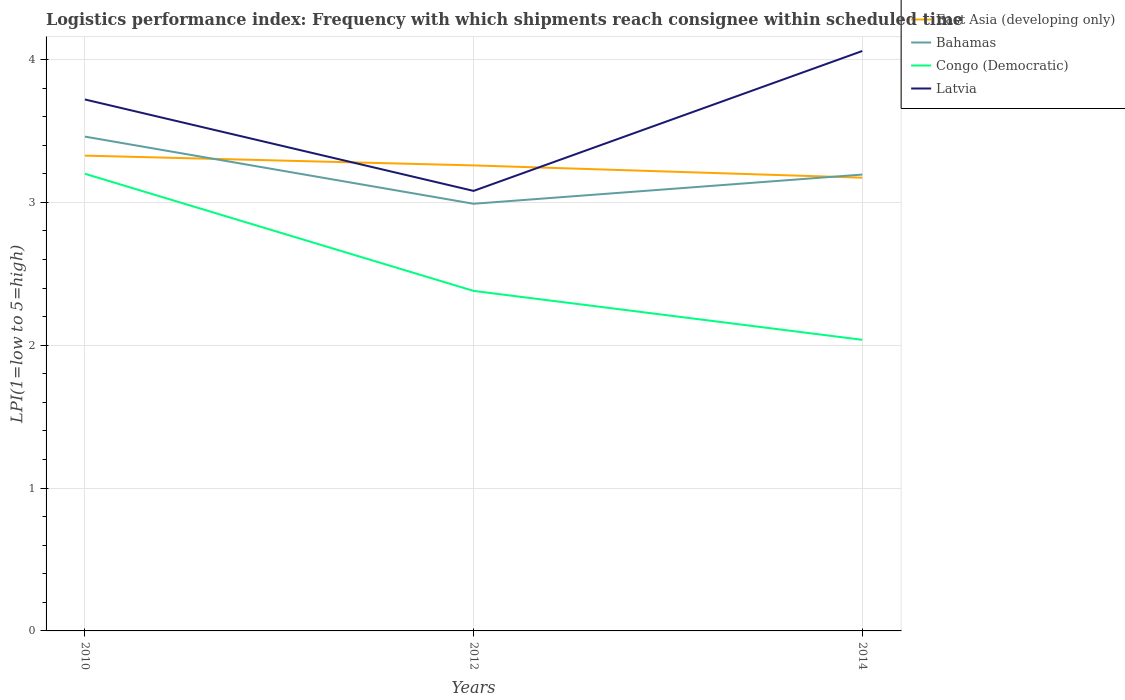Across all years, what is the maximum logistics performance index in East Asia (developing only)?
Offer a terse response. 3.17. In which year was the logistics performance index in Bahamas maximum?
Provide a succinct answer. 2012. What is the total logistics performance index in Latvia in the graph?
Provide a succinct answer. -0.34. What is the difference between the highest and the second highest logistics performance index in Congo (Democratic)?
Your answer should be very brief. 1.16. Is the logistics performance index in East Asia (developing only) strictly greater than the logistics performance index in Latvia over the years?
Give a very brief answer. No. How many lines are there?
Keep it short and to the point. 4. How many years are there in the graph?
Ensure brevity in your answer.  3. What is the difference between two consecutive major ticks on the Y-axis?
Your response must be concise. 1. Are the values on the major ticks of Y-axis written in scientific E-notation?
Keep it short and to the point. No. How many legend labels are there?
Make the answer very short. 4. What is the title of the graph?
Make the answer very short. Logistics performance index: Frequency with which shipments reach consignee within scheduled time. What is the label or title of the X-axis?
Make the answer very short. Years. What is the label or title of the Y-axis?
Ensure brevity in your answer.  LPI(1=low to 5=high). What is the LPI(1=low to 5=high) of East Asia (developing only) in 2010?
Keep it short and to the point. 3.33. What is the LPI(1=low to 5=high) in Bahamas in 2010?
Your answer should be very brief. 3.46. What is the LPI(1=low to 5=high) of Congo (Democratic) in 2010?
Offer a terse response. 3.2. What is the LPI(1=low to 5=high) of Latvia in 2010?
Give a very brief answer. 3.72. What is the LPI(1=low to 5=high) in East Asia (developing only) in 2012?
Your answer should be very brief. 3.26. What is the LPI(1=low to 5=high) in Bahamas in 2012?
Ensure brevity in your answer.  2.99. What is the LPI(1=low to 5=high) of Congo (Democratic) in 2012?
Keep it short and to the point. 2.38. What is the LPI(1=low to 5=high) in Latvia in 2012?
Your answer should be compact. 3.08. What is the LPI(1=low to 5=high) in East Asia (developing only) in 2014?
Your response must be concise. 3.17. What is the LPI(1=low to 5=high) of Bahamas in 2014?
Ensure brevity in your answer.  3.19. What is the LPI(1=low to 5=high) in Congo (Democratic) in 2014?
Keep it short and to the point. 2.04. What is the LPI(1=low to 5=high) in Latvia in 2014?
Provide a succinct answer. 4.06. Across all years, what is the maximum LPI(1=low to 5=high) in East Asia (developing only)?
Offer a very short reply. 3.33. Across all years, what is the maximum LPI(1=low to 5=high) in Bahamas?
Provide a short and direct response. 3.46. Across all years, what is the maximum LPI(1=low to 5=high) in Latvia?
Your answer should be very brief. 4.06. Across all years, what is the minimum LPI(1=low to 5=high) of East Asia (developing only)?
Ensure brevity in your answer.  3.17. Across all years, what is the minimum LPI(1=low to 5=high) of Bahamas?
Keep it short and to the point. 2.99. Across all years, what is the minimum LPI(1=low to 5=high) of Congo (Democratic)?
Provide a succinct answer. 2.04. Across all years, what is the minimum LPI(1=low to 5=high) in Latvia?
Make the answer very short. 3.08. What is the total LPI(1=low to 5=high) in East Asia (developing only) in the graph?
Ensure brevity in your answer.  9.76. What is the total LPI(1=low to 5=high) in Bahamas in the graph?
Your answer should be compact. 9.64. What is the total LPI(1=low to 5=high) of Congo (Democratic) in the graph?
Your answer should be compact. 7.62. What is the total LPI(1=low to 5=high) of Latvia in the graph?
Offer a very short reply. 10.86. What is the difference between the LPI(1=low to 5=high) of East Asia (developing only) in 2010 and that in 2012?
Offer a very short reply. 0.07. What is the difference between the LPI(1=low to 5=high) of Bahamas in 2010 and that in 2012?
Give a very brief answer. 0.47. What is the difference between the LPI(1=low to 5=high) in Congo (Democratic) in 2010 and that in 2012?
Your answer should be compact. 0.82. What is the difference between the LPI(1=low to 5=high) of Latvia in 2010 and that in 2012?
Your response must be concise. 0.64. What is the difference between the LPI(1=low to 5=high) of East Asia (developing only) in 2010 and that in 2014?
Your answer should be very brief. 0.15. What is the difference between the LPI(1=low to 5=high) in Bahamas in 2010 and that in 2014?
Provide a short and direct response. 0.27. What is the difference between the LPI(1=low to 5=high) of Congo (Democratic) in 2010 and that in 2014?
Offer a terse response. 1.16. What is the difference between the LPI(1=low to 5=high) of Latvia in 2010 and that in 2014?
Give a very brief answer. -0.34. What is the difference between the LPI(1=low to 5=high) of East Asia (developing only) in 2012 and that in 2014?
Offer a very short reply. 0.09. What is the difference between the LPI(1=low to 5=high) of Bahamas in 2012 and that in 2014?
Provide a succinct answer. -0.2. What is the difference between the LPI(1=low to 5=high) of Congo (Democratic) in 2012 and that in 2014?
Give a very brief answer. 0.34. What is the difference between the LPI(1=low to 5=high) in Latvia in 2012 and that in 2014?
Offer a terse response. -0.98. What is the difference between the LPI(1=low to 5=high) of East Asia (developing only) in 2010 and the LPI(1=low to 5=high) of Bahamas in 2012?
Offer a terse response. 0.34. What is the difference between the LPI(1=low to 5=high) in East Asia (developing only) in 2010 and the LPI(1=low to 5=high) in Congo (Democratic) in 2012?
Offer a terse response. 0.95. What is the difference between the LPI(1=low to 5=high) in East Asia (developing only) in 2010 and the LPI(1=low to 5=high) in Latvia in 2012?
Your answer should be very brief. 0.25. What is the difference between the LPI(1=low to 5=high) of Bahamas in 2010 and the LPI(1=low to 5=high) of Latvia in 2012?
Give a very brief answer. 0.38. What is the difference between the LPI(1=low to 5=high) in Congo (Democratic) in 2010 and the LPI(1=low to 5=high) in Latvia in 2012?
Keep it short and to the point. 0.12. What is the difference between the LPI(1=low to 5=high) in East Asia (developing only) in 2010 and the LPI(1=low to 5=high) in Bahamas in 2014?
Make the answer very short. 0.13. What is the difference between the LPI(1=low to 5=high) in East Asia (developing only) in 2010 and the LPI(1=low to 5=high) in Congo (Democratic) in 2014?
Provide a succinct answer. 1.29. What is the difference between the LPI(1=low to 5=high) of East Asia (developing only) in 2010 and the LPI(1=low to 5=high) of Latvia in 2014?
Ensure brevity in your answer.  -0.73. What is the difference between the LPI(1=low to 5=high) in Bahamas in 2010 and the LPI(1=low to 5=high) in Congo (Democratic) in 2014?
Keep it short and to the point. 1.42. What is the difference between the LPI(1=low to 5=high) of Bahamas in 2010 and the LPI(1=low to 5=high) of Latvia in 2014?
Ensure brevity in your answer.  -0.6. What is the difference between the LPI(1=low to 5=high) of Congo (Democratic) in 2010 and the LPI(1=low to 5=high) of Latvia in 2014?
Offer a very short reply. -0.86. What is the difference between the LPI(1=low to 5=high) of East Asia (developing only) in 2012 and the LPI(1=low to 5=high) of Bahamas in 2014?
Your answer should be compact. 0.06. What is the difference between the LPI(1=low to 5=high) of East Asia (developing only) in 2012 and the LPI(1=low to 5=high) of Congo (Democratic) in 2014?
Give a very brief answer. 1.22. What is the difference between the LPI(1=low to 5=high) of East Asia (developing only) in 2012 and the LPI(1=low to 5=high) of Latvia in 2014?
Give a very brief answer. -0.8. What is the difference between the LPI(1=low to 5=high) of Bahamas in 2012 and the LPI(1=low to 5=high) of Congo (Democratic) in 2014?
Keep it short and to the point. 0.95. What is the difference between the LPI(1=low to 5=high) in Bahamas in 2012 and the LPI(1=low to 5=high) in Latvia in 2014?
Keep it short and to the point. -1.07. What is the difference between the LPI(1=low to 5=high) in Congo (Democratic) in 2012 and the LPI(1=low to 5=high) in Latvia in 2014?
Make the answer very short. -1.68. What is the average LPI(1=low to 5=high) in East Asia (developing only) per year?
Make the answer very short. 3.25. What is the average LPI(1=low to 5=high) of Bahamas per year?
Your answer should be very brief. 3.21. What is the average LPI(1=low to 5=high) in Congo (Democratic) per year?
Provide a short and direct response. 2.54. What is the average LPI(1=low to 5=high) in Latvia per year?
Your answer should be compact. 3.62. In the year 2010, what is the difference between the LPI(1=low to 5=high) of East Asia (developing only) and LPI(1=low to 5=high) of Bahamas?
Ensure brevity in your answer.  -0.13. In the year 2010, what is the difference between the LPI(1=low to 5=high) in East Asia (developing only) and LPI(1=low to 5=high) in Congo (Democratic)?
Provide a short and direct response. 0.13. In the year 2010, what is the difference between the LPI(1=low to 5=high) in East Asia (developing only) and LPI(1=low to 5=high) in Latvia?
Make the answer very short. -0.39. In the year 2010, what is the difference between the LPI(1=low to 5=high) in Bahamas and LPI(1=low to 5=high) in Congo (Democratic)?
Keep it short and to the point. 0.26. In the year 2010, what is the difference between the LPI(1=low to 5=high) of Bahamas and LPI(1=low to 5=high) of Latvia?
Provide a succinct answer. -0.26. In the year 2010, what is the difference between the LPI(1=low to 5=high) of Congo (Democratic) and LPI(1=low to 5=high) of Latvia?
Keep it short and to the point. -0.52. In the year 2012, what is the difference between the LPI(1=low to 5=high) in East Asia (developing only) and LPI(1=low to 5=high) in Bahamas?
Your response must be concise. 0.27. In the year 2012, what is the difference between the LPI(1=low to 5=high) of East Asia (developing only) and LPI(1=low to 5=high) of Congo (Democratic)?
Your response must be concise. 0.88. In the year 2012, what is the difference between the LPI(1=low to 5=high) in East Asia (developing only) and LPI(1=low to 5=high) in Latvia?
Make the answer very short. 0.18. In the year 2012, what is the difference between the LPI(1=low to 5=high) of Bahamas and LPI(1=low to 5=high) of Congo (Democratic)?
Your response must be concise. 0.61. In the year 2012, what is the difference between the LPI(1=low to 5=high) of Bahamas and LPI(1=low to 5=high) of Latvia?
Your answer should be compact. -0.09. In the year 2012, what is the difference between the LPI(1=low to 5=high) of Congo (Democratic) and LPI(1=low to 5=high) of Latvia?
Give a very brief answer. -0.7. In the year 2014, what is the difference between the LPI(1=low to 5=high) of East Asia (developing only) and LPI(1=low to 5=high) of Bahamas?
Provide a short and direct response. -0.02. In the year 2014, what is the difference between the LPI(1=low to 5=high) of East Asia (developing only) and LPI(1=low to 5=high) of Congo (Democratic)?
Offer a terse response. 1.13. In the year 2014, what is the difference between the LPI(1=low to 5=high) of East Asia (developing only) and LPI(1=low to 5=high) of Latvia?
Ensure brevity in your answer.  -0.89. In the year 2014, what is the difference between the LPI(1=low to 5=high) of Bahamas and LPI(1=low to 5=high) of Congo (Democratic)?
Make the answer very short. 1.16. In the year 2014, what is the difference between the LPI(1=low to 5=high) of Bahamas and LPI(1=low to 5=high) of Latvia?
Your answer should be very brief. -0.86. In the year 2014, what is the difference between the LPI(1=low to 5=high) of Congo (Democratic) and LPI(1=low to 5=high) of Latvia?
Offer a terse response. -2.02. What is the ratio of the LPI(1=low to 5=high) in East Asia (developing only) in 2010 to that in 2012?
Provide a succinct answer. 1.02. What is the ratio of the LPI(1=low to 5=high) in Bahamas in 2010 to that in 2012?
Keep it short and to the point. 1.16. What is the ratio of the LPI(1=low to 5=high) of Congo (Democratic) in 2010 to that in 2012?
Your answer should be compact. 1.34. What is the ratio of the LPI(1=low to 5=high) in Latvia in 2010 to that in 2012?
Your answer should be compact. 1.21. What is the ratio of the LPI(1=low to 5=high) in East Asia (developing only) in 2010 to that in 2014?
Make the answer very short. 1.05. What is the ratio of the LPI(1=low to 5=high) in Bahamas in 2010 to that in 2014?
Provide a succinct answer. 1.08. What is the ratio of the LPI(1=low to 5=high) of Congo (Democratic) in 2010 to that in 2014?
Provide a short and direct response. 1.57. What is the ratio of the LPI(1=low to 5=high) of Latvia in 2010 to that in 2014?
Your answer should be compact. 0.92. What is the ratio of the LPI(1=low to 5=high) of East Asia (developing only) in 2012 to that in 2014?
Your response must be concise. 1.03. What is the ratio of the LPI(1=low to 5=high) in Bahamas in 2012 to that in 2014?
Make the answer very short. 0.94. What is the ratio of the LPI(1=low to 5=high) in Congo (Democratic) in 2012 to that in 2014?
Provide a short and direct response. 1.17. What is the ratio of the LPI(1=low to 5=high) in Latvia in 2012 to that in 2014?
Keep it short and to the point. 0.76. What is the difference between the highest and the second highest LPI(1=low to 5=high) of East Asia (developing only)?
Your response must be concise. 0.07. What is the difference between the highest and the second highest LPI(1=low to 5=high) of Bahamas?
Make the answer very short. 0.27. What is the difference between the highest and the second highest LPI(1=low to 5=high) in Congo (Democratic)?
Keep it short and to the point. 0.82. What is the difference between the highest and the second highest LPI(1=low to 5=high) of Latvia?
Your answer should be very brief. 0.34. What is the difference between the highest and the lowest LPI(1=low to 5=high) in East Asia (developing only)?
Give a very brief answer. 0.15. What is the difference between the highest and the lowest LPI(1=low to 5=high) in Bahamas?
Your response must be concise. 0.47. What is the difference between the highest and the lowest LPI(1=low to 5=high) in Congo (Democratic)?
Provide a succinct answer. 1.16. What is the difference between the highest and the lowest LPI(1=low to 5=high) in Latvia?
Provide a short and direct response. 0.98. 